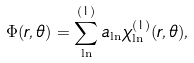Convert formula to latex. <formula><loc_0><loc_0><loc_500><loc_500>\Phi ( r , \theta ) = \sum _ { \ln } ^ { ( 1 ) } a _ { \ln } \chi _ { \ln } ^ { ( 1 ) } ( r , \theta ) ,</formula> 